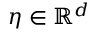<formula> <loc_0><loc_0><loc_500><loc_500>\eta \in \mathbb { R } ^ { d }</formula> 